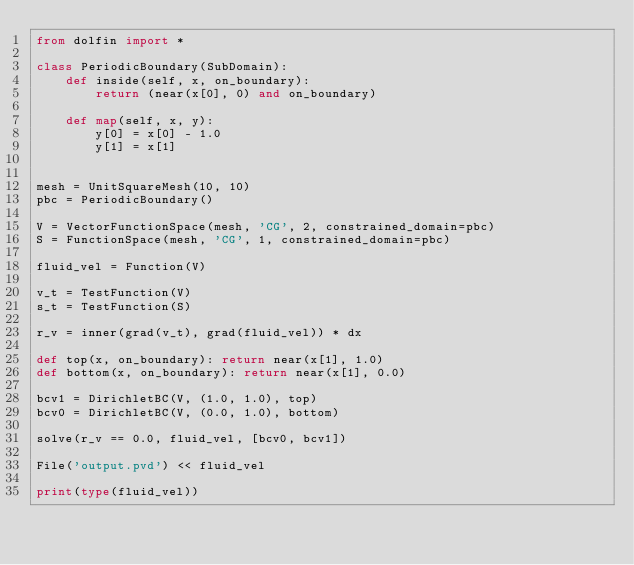Convert code to text. <code><loc_0><loc_0><loc_500><loc_500><_Python_>from dolfin import *

class PeriodicBoundary(SubDomain):
    def inside(self, x, on_boundary):
        return (near(x[0], 0) and on_boundary)

    def map(self, x, y):
        y[0] = x[0] - 1.0
        y[1] = x[1]


mesh = UnitSquareMesh(10, 10)
pbc = PeriodicBoundary()

V = VectorFunctionSpace(mesh, 'CG', 2, constrained_domain=pbc)
S = FunctionSpace(mesh, 'CG', 1, constrained_domain=pbc)

fluid_vel = Function(V)

v_t = TestFunction(V)
s_t = TestFunction(S)

r_v = inner(grad(v_t), grad(fluid_vel)) * dx

def top(x, on_boundary): return near(x[1], 1.0)
def bottom(x, on_boundary): return near(x[1], 0.0)

bcv1 = DirichletBC(V, (1.0, 1.0), top)
bcv0 = DirichletBC(V, (0.0, 1.0), bottom)

solve(r_v == 0.0, fluid_vel, [bcv0, bcv1])

File('output.pvd') << fluid_vel

print(type(fluid_vel))
</code> 